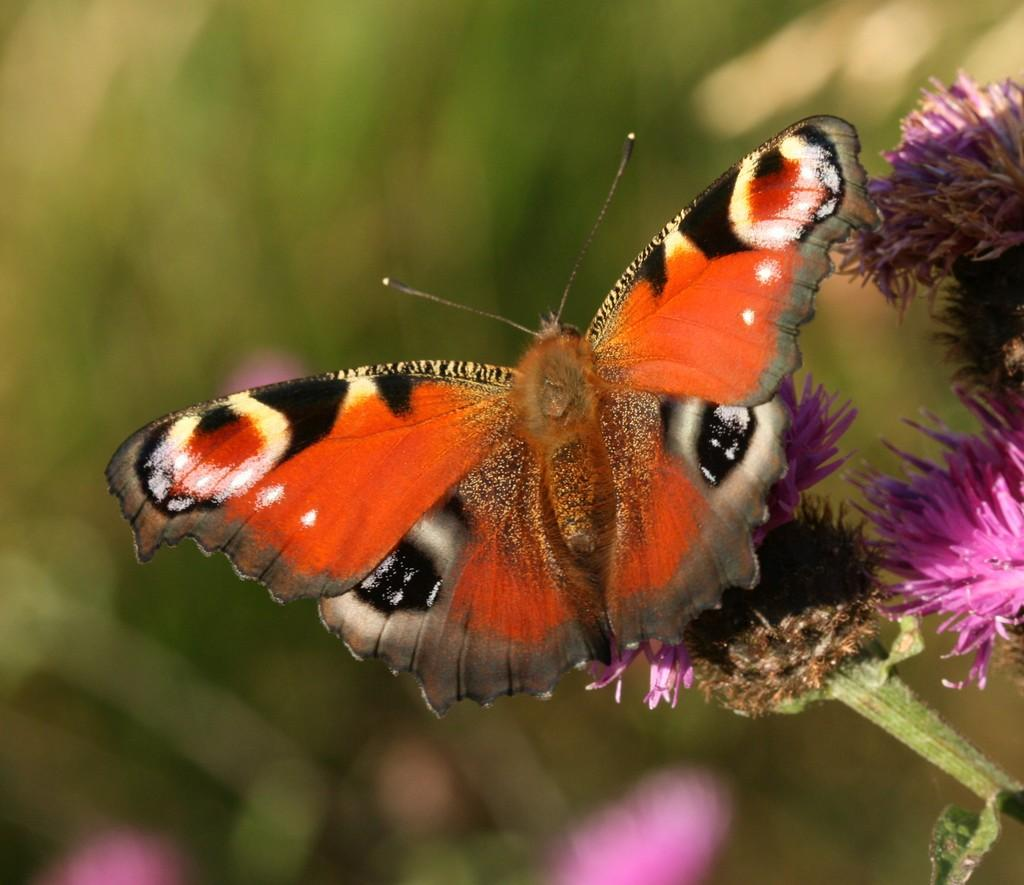What can be seen on the right side of the image? There are followers visible on the right side of the image. What type of creature is present in the image? There is a butterfly in the image. How would you describe the background of the image? The background of the image is blurry. How many chairs are visible in the image? There are no chairs present in the image. What is the rate of the butterfly's flight in the image? The image does not provide information about the butterfly's flight rate. 